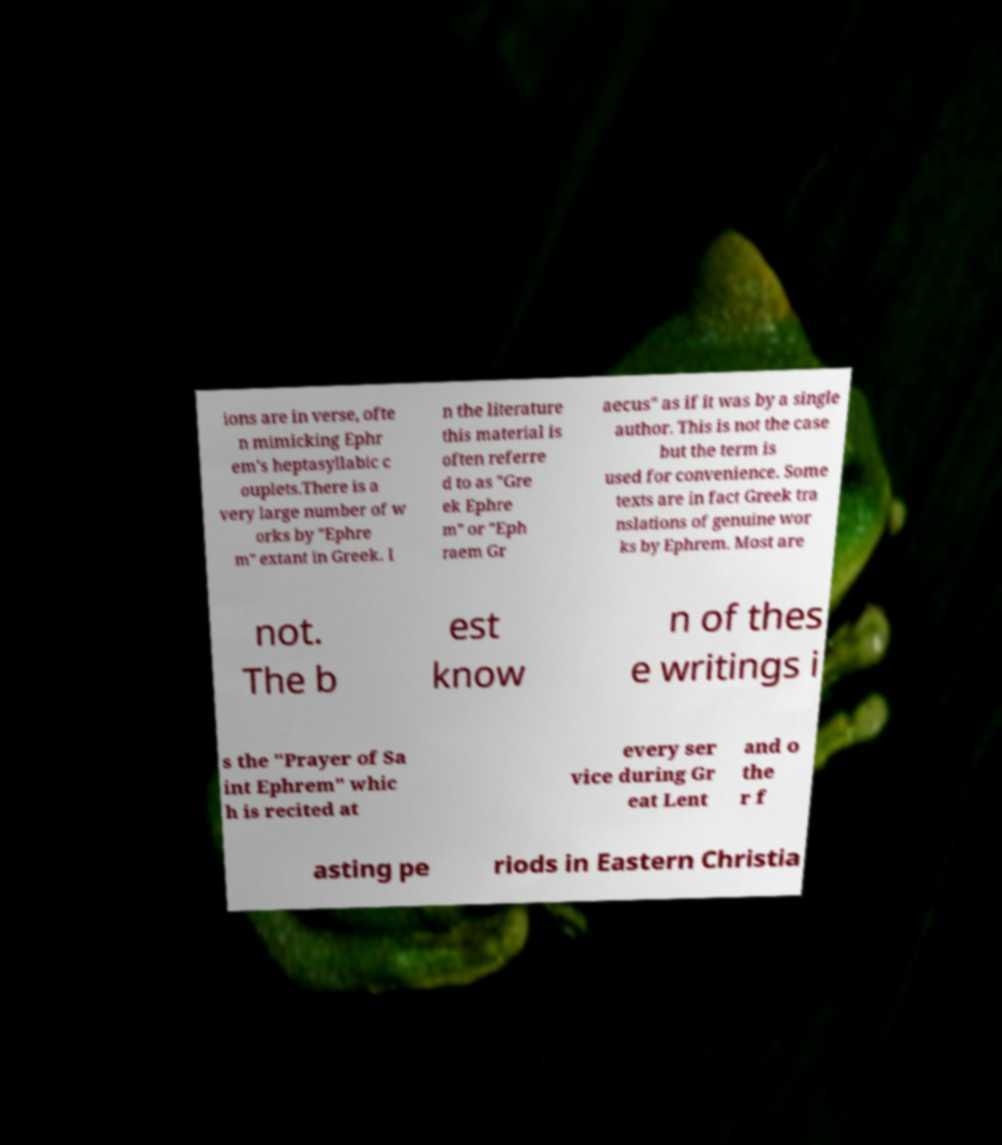Could you assist in decoding the text presented in this image and type it out clearly? ions are in verse, ofte n mimicking Ephr em's heptasyllabic c ouplets.There is a very large number of w orks by "Ephre m" extant in Greek. I n the literature this material is often referre d to as "Gre ek Ephre m" or "Eph raem Gr aecus" as if it was by a single author. This is not the case but the term is used for convenience. Some texts are in fact Greek tra nslations of genuine wor ks by Ephrem. Most are not. The b est know n of thes e writings i s the "Prayer of Sa int Ephrem" whic h is recited at every ser vice during Gr eat Lent and o the r f asting pe riods in Eastern Christia 